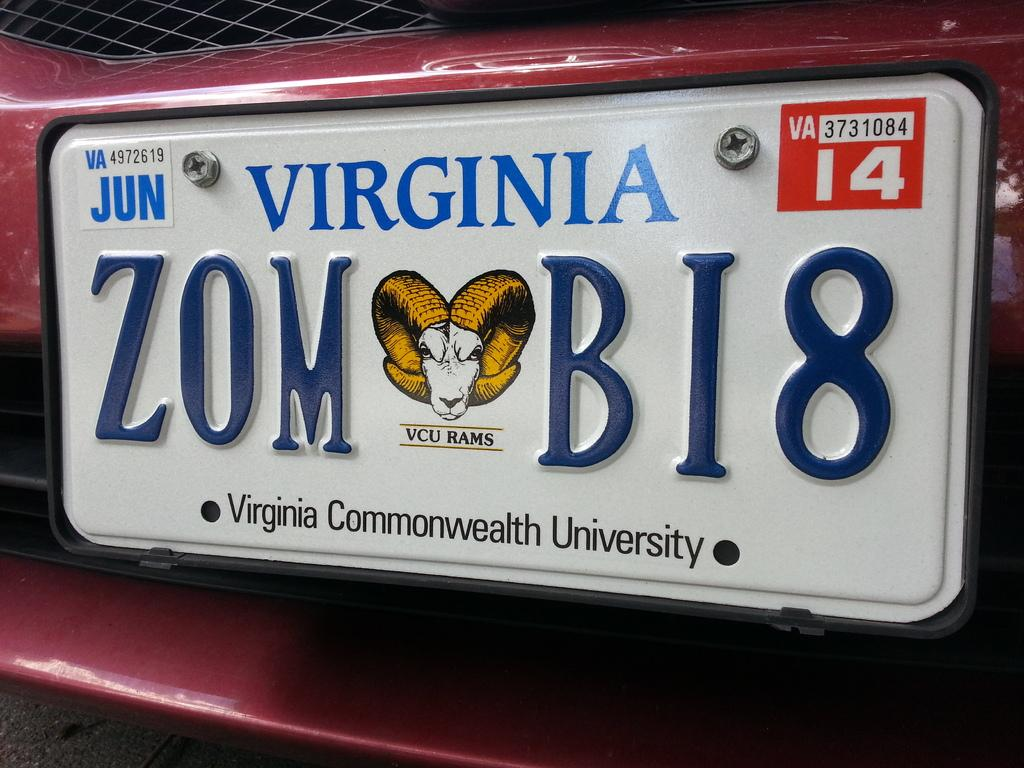<image>
Share a concise interpretation of the image provided. Virginia plate number ZOM BI8 expires in 2014. 